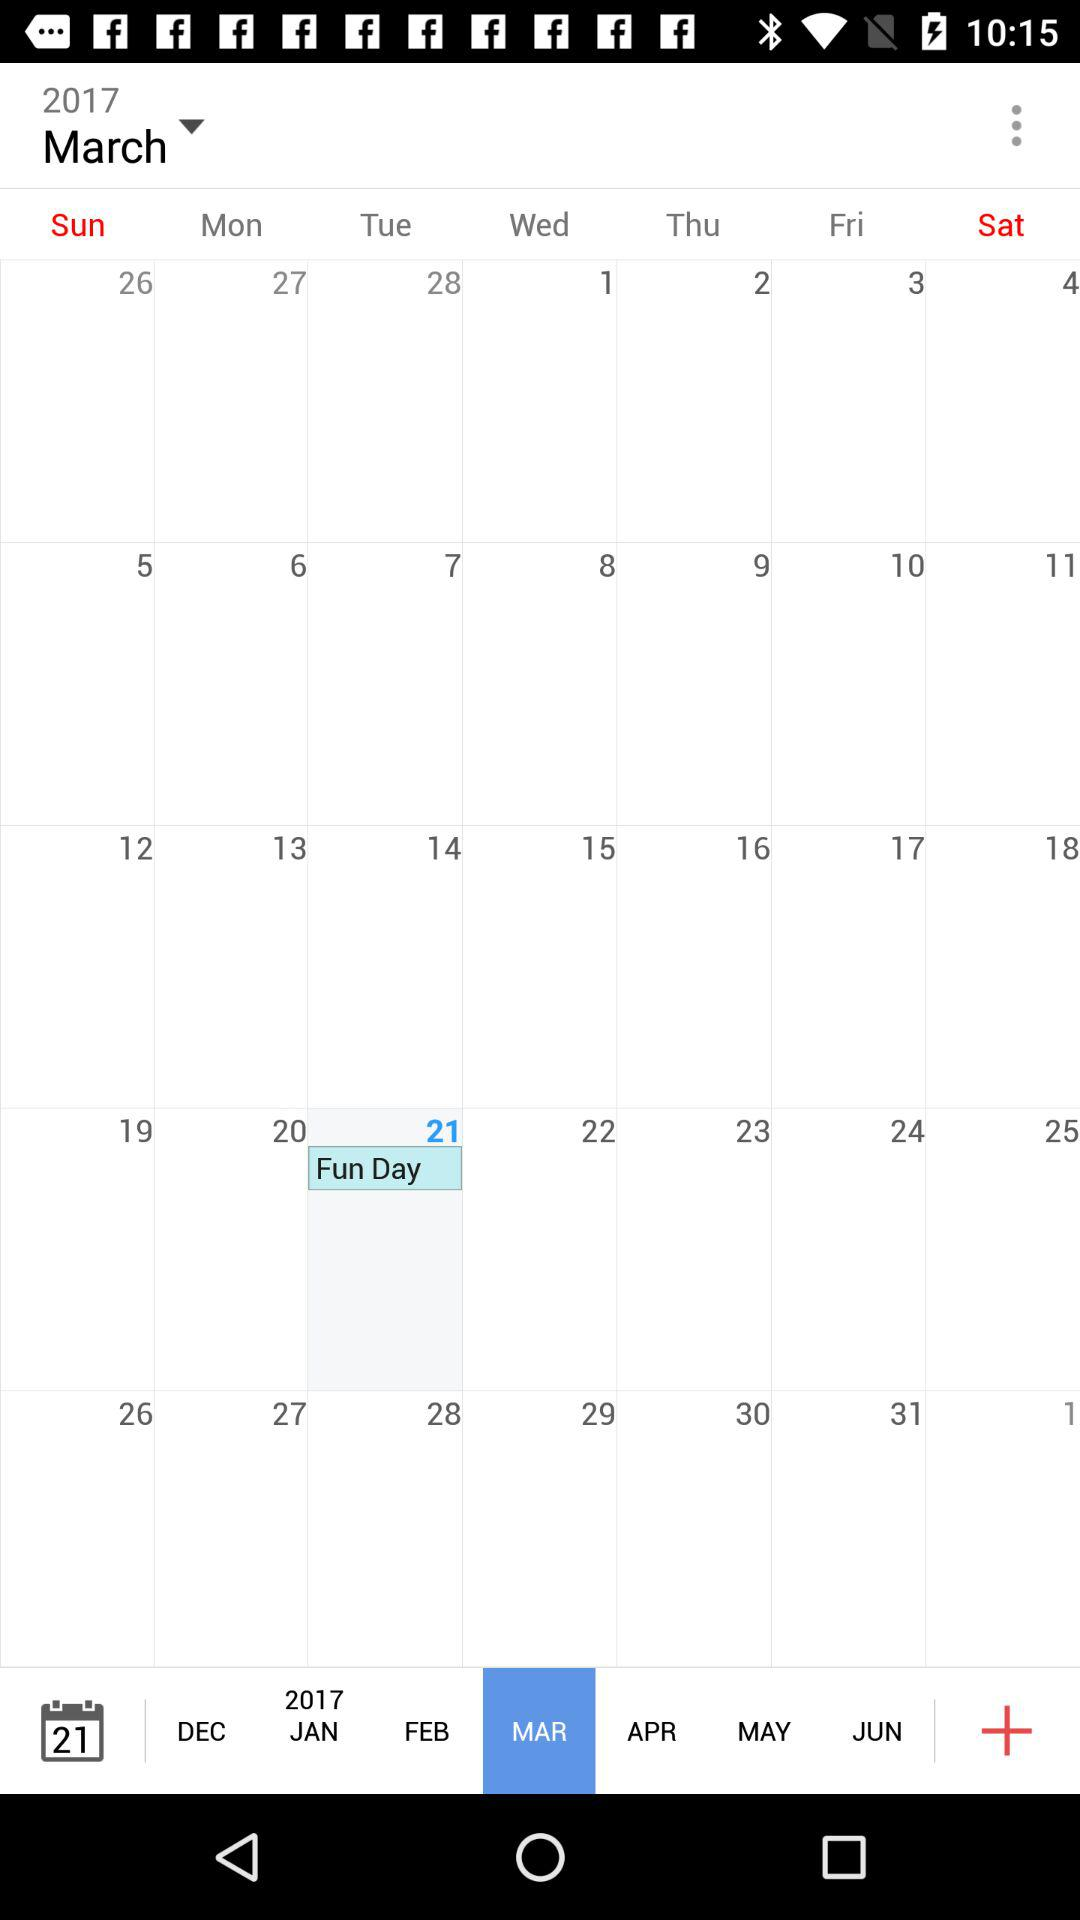On the calendar, what year is it? The year is 2017. 